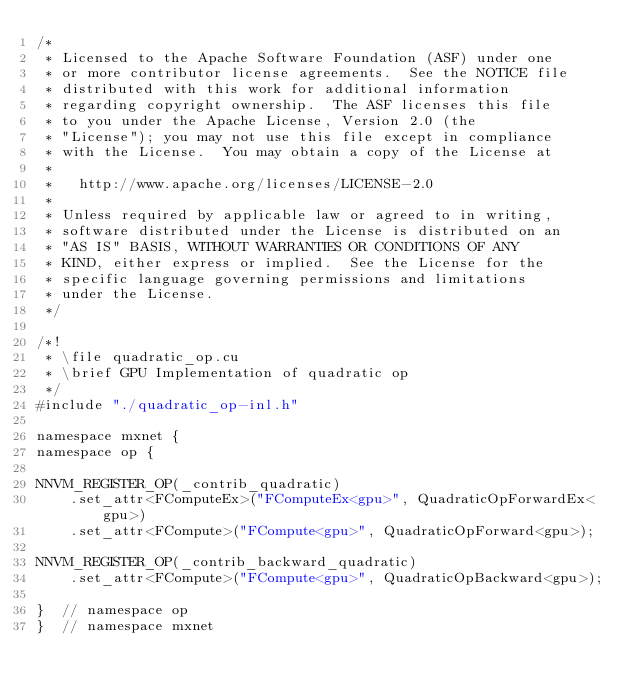Convert code to text. <code><loc_0><loc_0><loc_500><loc_500><_Cuda_>/*
 * Licensed to the Apache Software Foundation (ASF) under one
 * or more contributor license agreements.  See the NOTICE file
 * distributed with this work for additional information
 * regarding copyright ownership.  The ASF licenses this file
 * to you under the Apache License, Version 2.0 (the
 * "License"); you may not use this file except in compliance
 * with the License.  You may obtain a copy of the License at
 *
 *   http://www.apache.org/licenses/LICENSE-2.0
 *
 * Unless required by applicable law or agreed to in writing,
 * software distributed under the License is distributed on an
 * "AS IS" BASIS, WITHOUT WARRANTIES OR CONDITIONS OF ANY
 * KIND, either express or implied.  See the License for the
 * specific language governing permissions and limitations
 * under the License.
 */

/*!
 * \file quadratic_op.cu
 * \brief GPU Implementation of quadratic op
 */
#include "./quadratic_op-inl.h"

namespace mxnet {
namespace op {

NNVM_REGISTER_OP(_contrib_quadratic)
    .set_attr<FComputeEx>("FComputeEx<gpu>", QuadraticOpForwardEx<gpu>)
    .set_attr<FCompute>("FCompute<gpu>", QuadraticOpForward<gpu>);

NNVM_REGISTER_OP(_contrib_backward_quadratic)
    .set_attr<FCompute>("FCompute<gpu>", QuadraticOpBackward<gpu>);

}  // namespace op
}  // namespace mxnet
</code> 